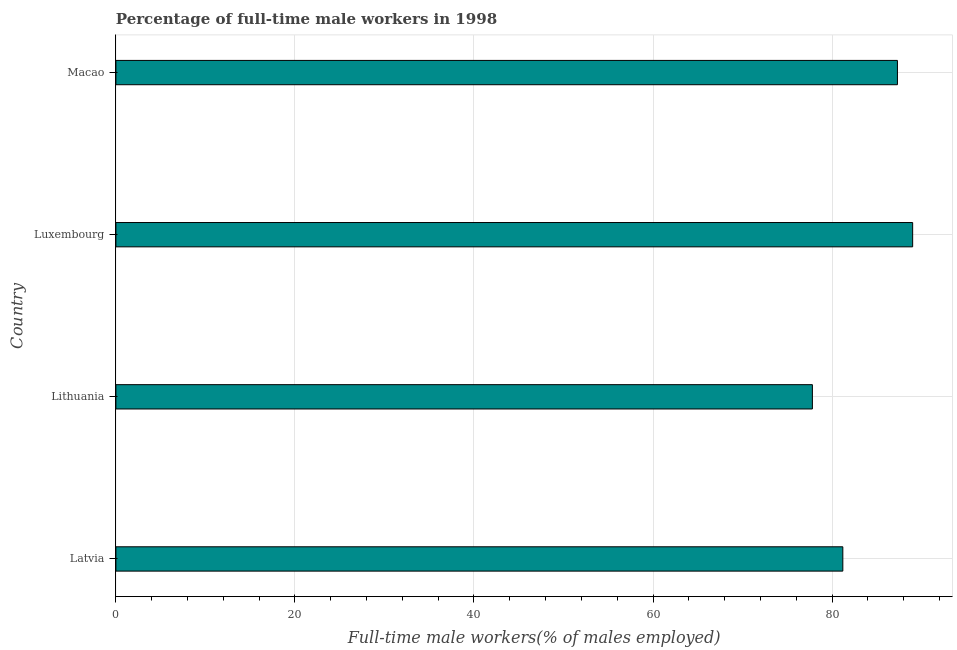What is the title of the graph?
Keep it short and to the point. Percentage of full-time male workers in 1998. What is the label or title of the X-axis?
Provide a short and direct response. Full-time male workers(% of males employed). What is the percentage of full-time male workers in Luxembourg?
Keep it short and to the point. 89. Across all countries, what is the maximum percentage of full-time male workers?
Give a very brief answer. 89. Across all countries, what is the minimum percentage of full-time male workers?
Your answer should be very brief. 77.8. In which country was the percentage of full-time male workers maximum?
Provide a short and direct response. Luxembourg. In which country was the percentage of full-time male workers minimum?
Your answer should be very brief. Lithuania. What is the sum of the percentage of full-time male workers?
Provide a succinct answer. 335.3. What is the average percentage of full-time male workers per country?
Make the answer very short. 83.83. What is the median percentage of full-time male workers?
Keep it short and to the point. 84.25. What is the ratio of the percentage of full-time male workers in Latvia to that in Lithuania?
Offer a terse response. 1.04. Is the difference between the percentage of full-time male workers in Luxembourg and Macao greater than the difference between any two countries?
Provide a succinct answer. No. What is the difference between the highest and the second highest percentage of full-time male workers?
Give a very brief answer. 1.7. Are all the bars in the graph horizontal?
Keep it short and to the point. Yes. How many countries are there in the graph?
Ensure brevity in your answer.  4. What is the difference between two consecutive major ticks on the X-axis?
Your response must be concise. 20. What is the Full-time male workers(% of males employed) in Latvia?
Offer a very short reply. 81.2. What is the Full-time male workers(% of males employed) of Lithuania?
Your answer should be very brief. 77.8. What is the Full-time male workers(% of males employed) in Luxembourg?
Your answer should be very brief. 89. What is the Full-time male workers(% of males employed) of Macao?
Provide a succinct answer. 87.3. What is the difference between the Full-time male workers(% of males employed) in Latvia and Lithuania?
Your answer should be very brief. 3.4. What is the difference between the Full-time male workers(% of males employed) in Latvia and Macao?
Your answer should be very brief. -6.1. What is the difference between the Full-time male workers(% of males employed) in Luxembourg and Macao?
Make the answer very short. 1.7. What is the ratio of the Full-time male workers(% of males employed) in Latvia to that in Lithuania?
Provide a short and direct response. 1.04. What is the ratio of the Full-time male workers(% of males employed) in Latvia to that in Luxembourg?
Give a very brief answer. 0.91. What is the ratio of the Full-time male workers(% of males employed) in Latvia to that in Macao?
Keep it short and to the point. 0.93. What is the ratio of the Full-time male workers(% of males employed) in Lithuania to that in Luxembourg?
Offer a very short reply. 0.87. What is the ratio of the Full-time male workers(% of males employed) in Lithuania to that in Macao?
Give a very brief answer. 0.89. 